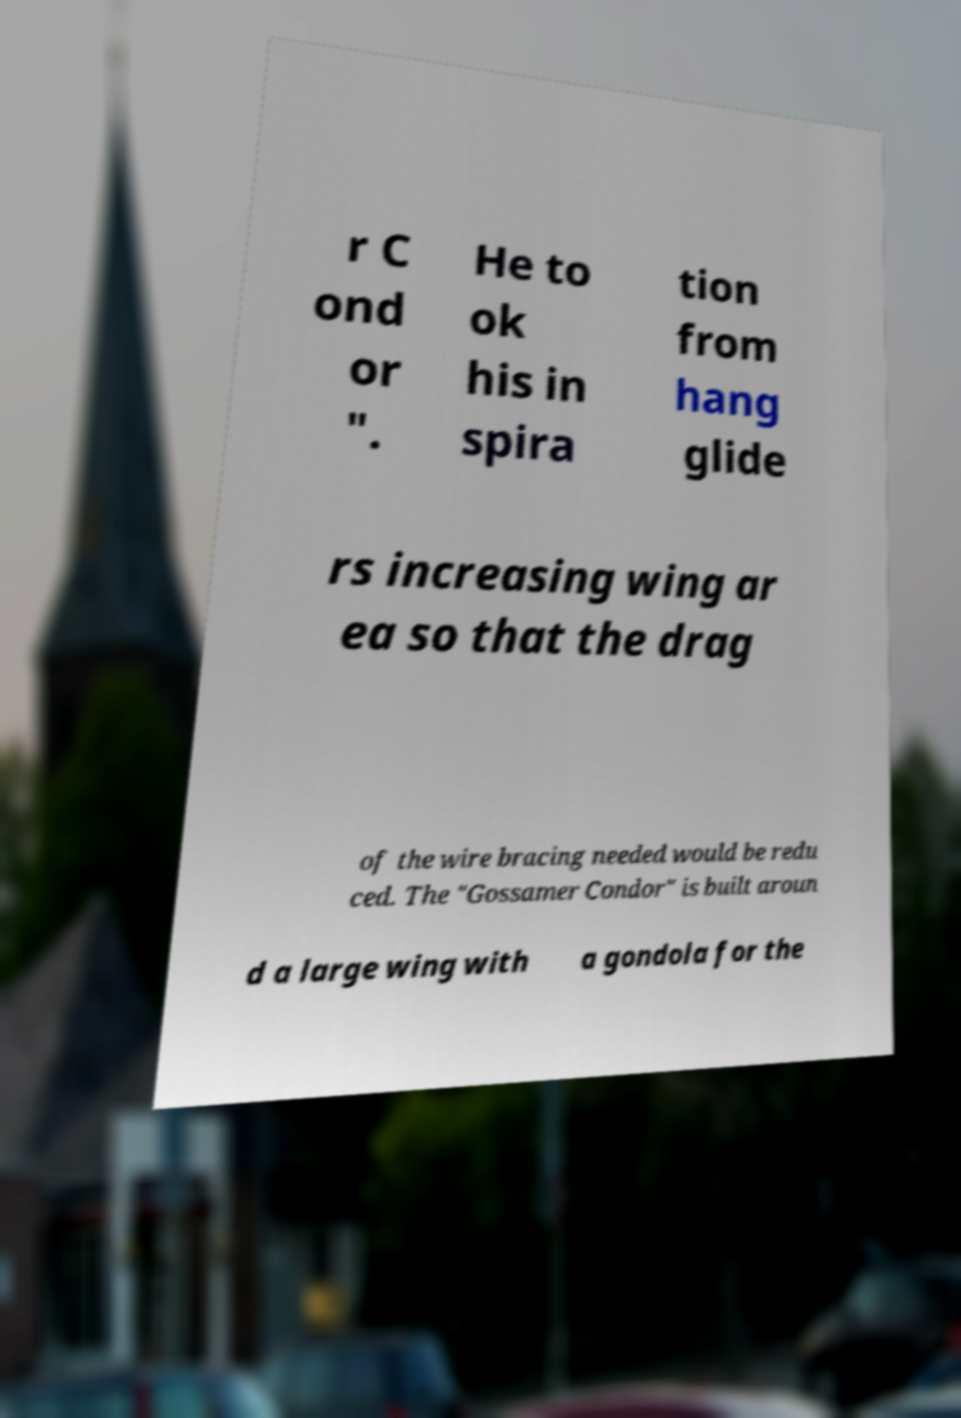For documentation purposes, I need the text within this image transcribed. Could you provide that? r C ond or ". He to ok his in spira tion from hang glide rs increasing wing ar ea so that the drag of the wire bracing needed would be redu ced. The "Gossamer Condor" is built aroun d a large wing with a gondola for the 